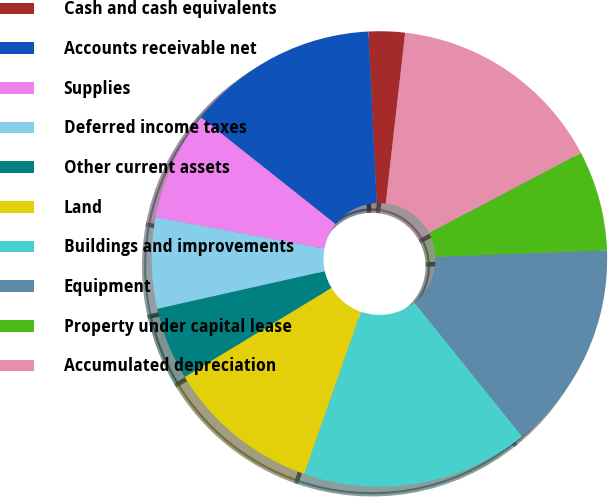Convert chart. <chart><loc_0><loc_0><loc_500><loc_500><pie_chart><fcel>Cash and cash equivalents<fcel>Accounts receivable net<fcel>Supplies<fcel>Deferred income taxes<fcel>Other current assets<fcel>Land<fcel>Buildings and improvements<fcel>Equipment<fcel>Property under capital lease<fcel>Accumulated depreciation<nl><fcel>2.58%<fcel>13.55%<fcel>7.74%<fcel>6.45%<fcel>5.16%<fcel>10.97%<fcel>16.13%<fcel>14.84%<fcel>7.1%<fcel>15.48%<nl></chart> 